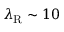Convert formula to latex. <formula><loc_0><loc_0><loc_500><loc_500>\lambda _ { R } \sim 1 0</formula> 